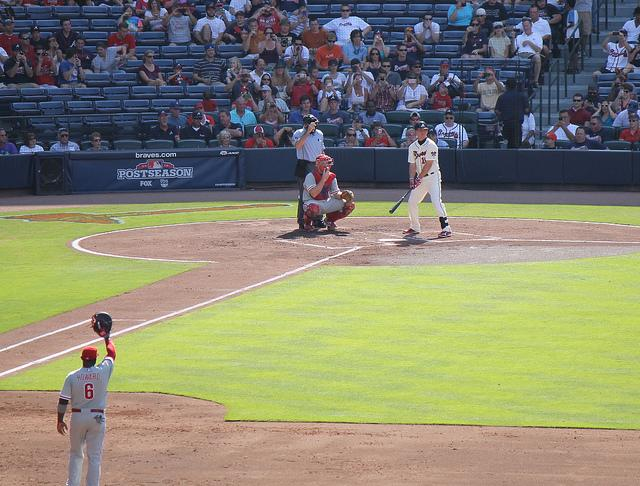What switch hitting Atlanta Braves legend is at the plate? Please explain your reasoning. chipper jones. This would be chipper jones. 